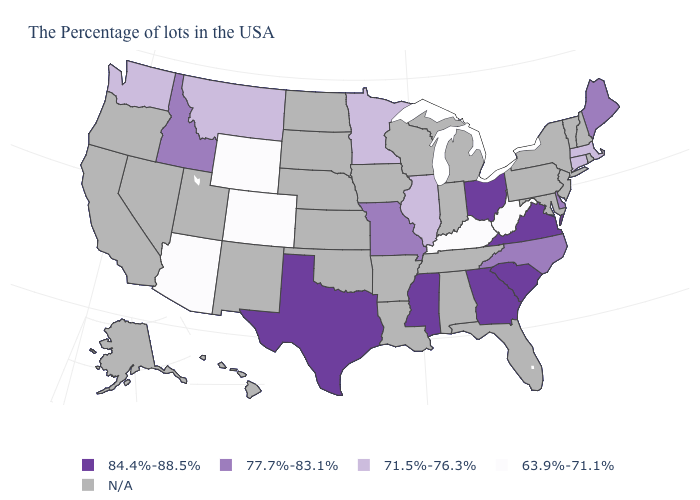What is the value of North Carolina?
Quick response, please. 77.7%-83.1%. What is the value of New Hampshire?
Give a very brief answer. N/A. What is the value of Tennessee?
Short answer required. N/A. Among the states that border New Mexico , which have the highest value?
Write a very short answer. Texas. Name the states that have a value in the range 77.7%-83.1%?
Short answer required. Maine, Delaware, North Carolina, Missouri, Idaho. What is the value of Washington?
Short answer required. 71.5%-76.3%. Name the states that have a value in the range 71.5%-76.3%?
Keep it brief. Massachusetts, Connecticut, Illinois, Minnesota, Montana, Washington. What is the value of New Hampshire?
Keep it brief. N/A. Among the states that border Oregon , which have the lowest value?
Be succinct. Washington. Name the states that have a value in the range 63.9%-71.1%?
Keep it brief. West Virginia, Kentucky, Wyoming, Colorado, Arizona. What is the value of Missouri?
Give a very brief answer. 77.7%-83.1%. What is the value of Michigan?
Write a very short answer. N/A. Name the states that have a value in the range 71.5%-76.3%?
Keep it brief. Massachusetts, Connecticut, Illinois, Minnesota, Montana, Washington. Name the states that have a value in the range 84.4%-88.5%?
Give a very brief answer. Virginia, South Carolina, Ohio, Georgia, Mississippi, Texas. 